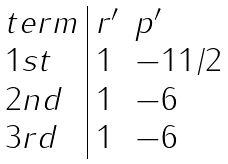<formula> <loc_0><loc_0><loc_500><loc_500>\begin{array} { l | l l } t e r m & r ^ { \prime } & p ^ { \prime } \\ 1 s t & 1 & - 1 1 / 2 \\ 2 n d & 1 & - 6 \\ 3 r d & 1 & - 6 \end{array}</formula> 